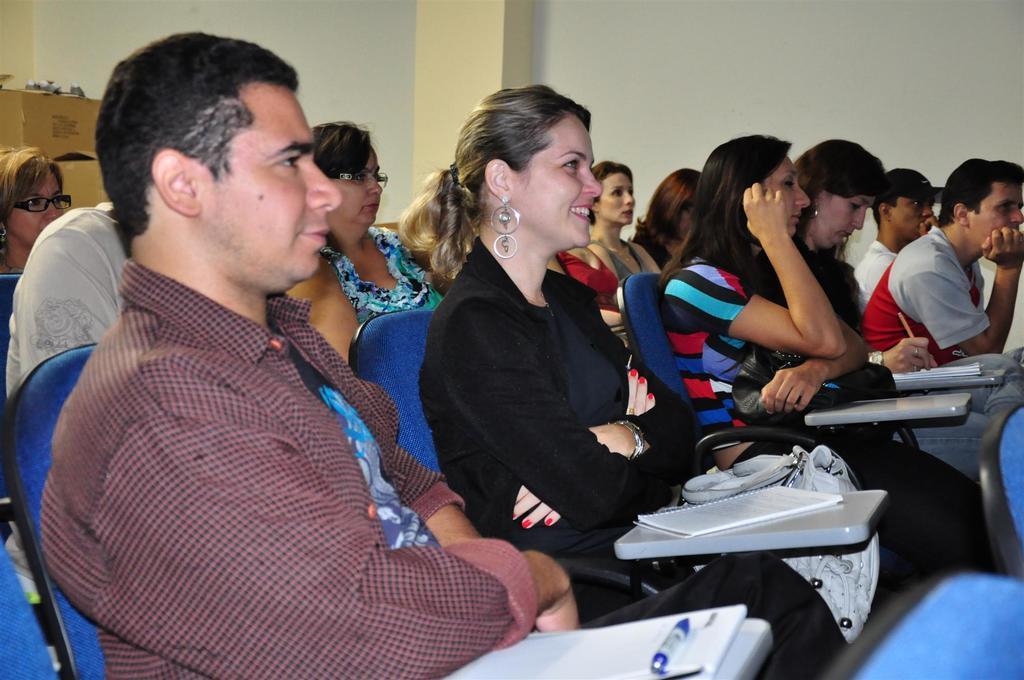Please provide a concise description of this image. There are groups of people sitting on the chairs. These look like the desks with the books and pens. This looks like a pillar. Here is a wall. On the left corner of the image, I think these are the cardboard boxes. 